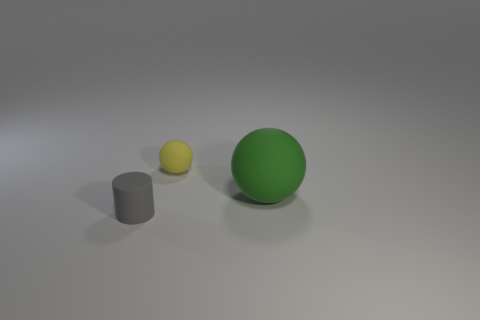What number of objects are in front of the yellow thing and to the right of the gray rubber cylinder?
Ensure brevity in your answer.  1. What number of gray things are either small cubes or small cylinders?
Make the answer very short. 1. There is a tiny object behind the tiny object that is in front of the tiny matte thing behind the large matte thing; what is its color?
Your answer should be compact. Yellow. Is there a large green matte object that is in front of the rubber thing behind the large green rubber thing?
Make the answer very short. Yes. There is a thing that is behind the big ball; does it have the same shape as the big matte thing?
Ensure brevity in your answer.  Yes. Is there anything else that is the same shape as the big rubber thing?
Make the answer very short. Yes. How many cylinders are either tiny yellow things or tiny gray objects?
Keep it short and to the point. 1. How many blue shiny objects are there?
Keep it short and to the point. 0. There is a object that is to the right of the object behind the green object; how big is it?
Keep it short and to the point. Large. What number of other objects are the same size as the green ball?
Provide a succinct answer. 0. 